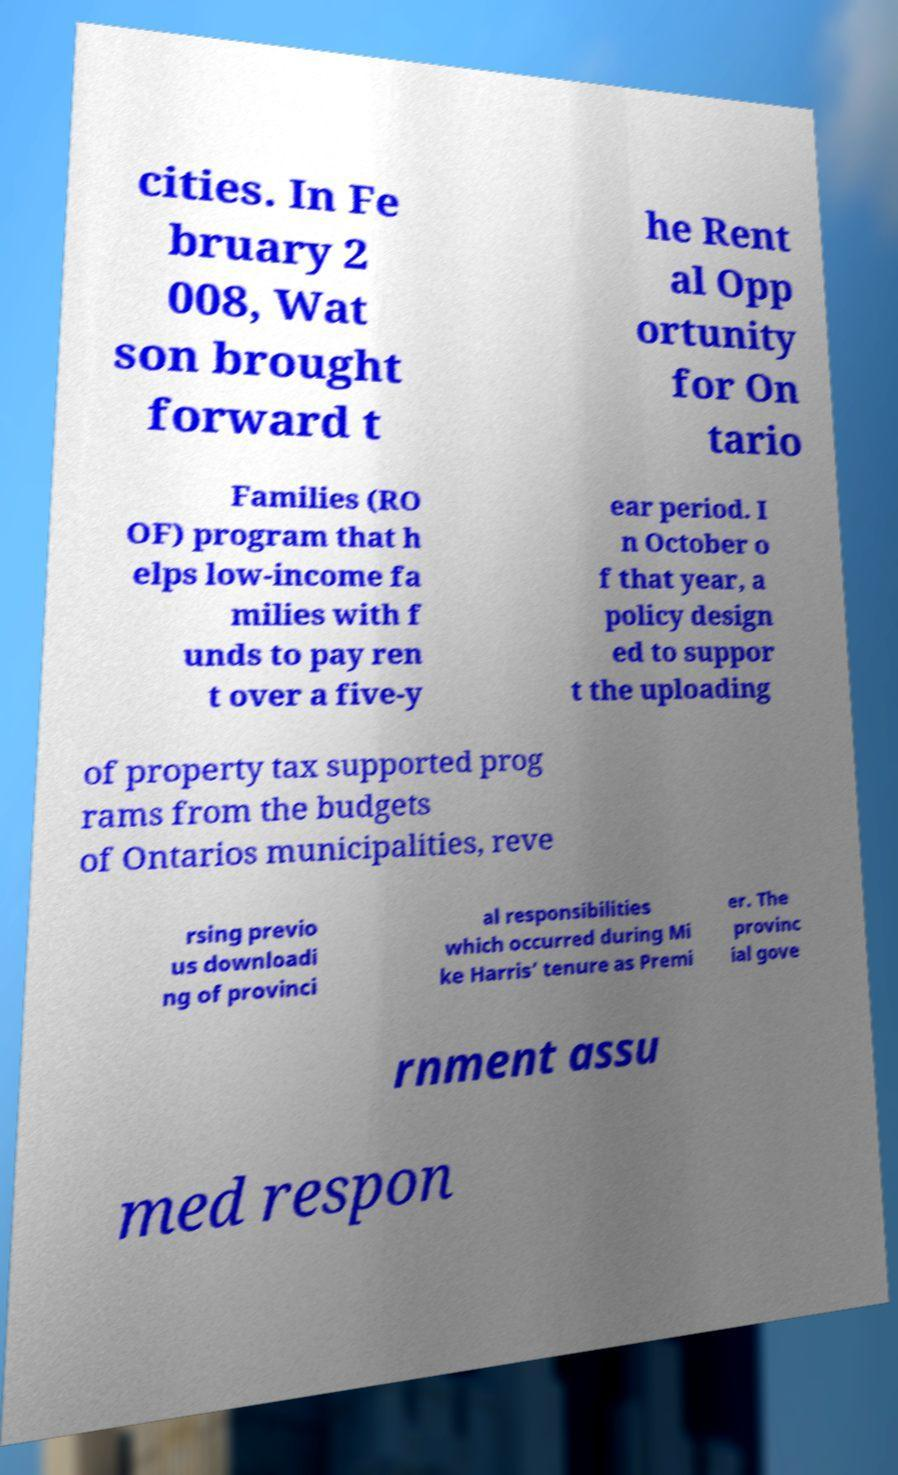Please identify and transcribe the text found in this image. cities. In Fe bruary 2 008, Wat son brought forward t he Rent al Opp ortunity for On tario Families (RO OF) program that h elps low-income fa milies with f unds to pay ren t over a five-y ear period. I n October o f that year, a policy design ed to suppor t the uploading of property tax supported prog rams from the budgets of Ontarios municipalities, reve rsing previo us downloadi ng of provinci al responsibilities which occurred during Mi ke Harris’ tenure as Premi er. The provinc ial gove rnment assu med respon 